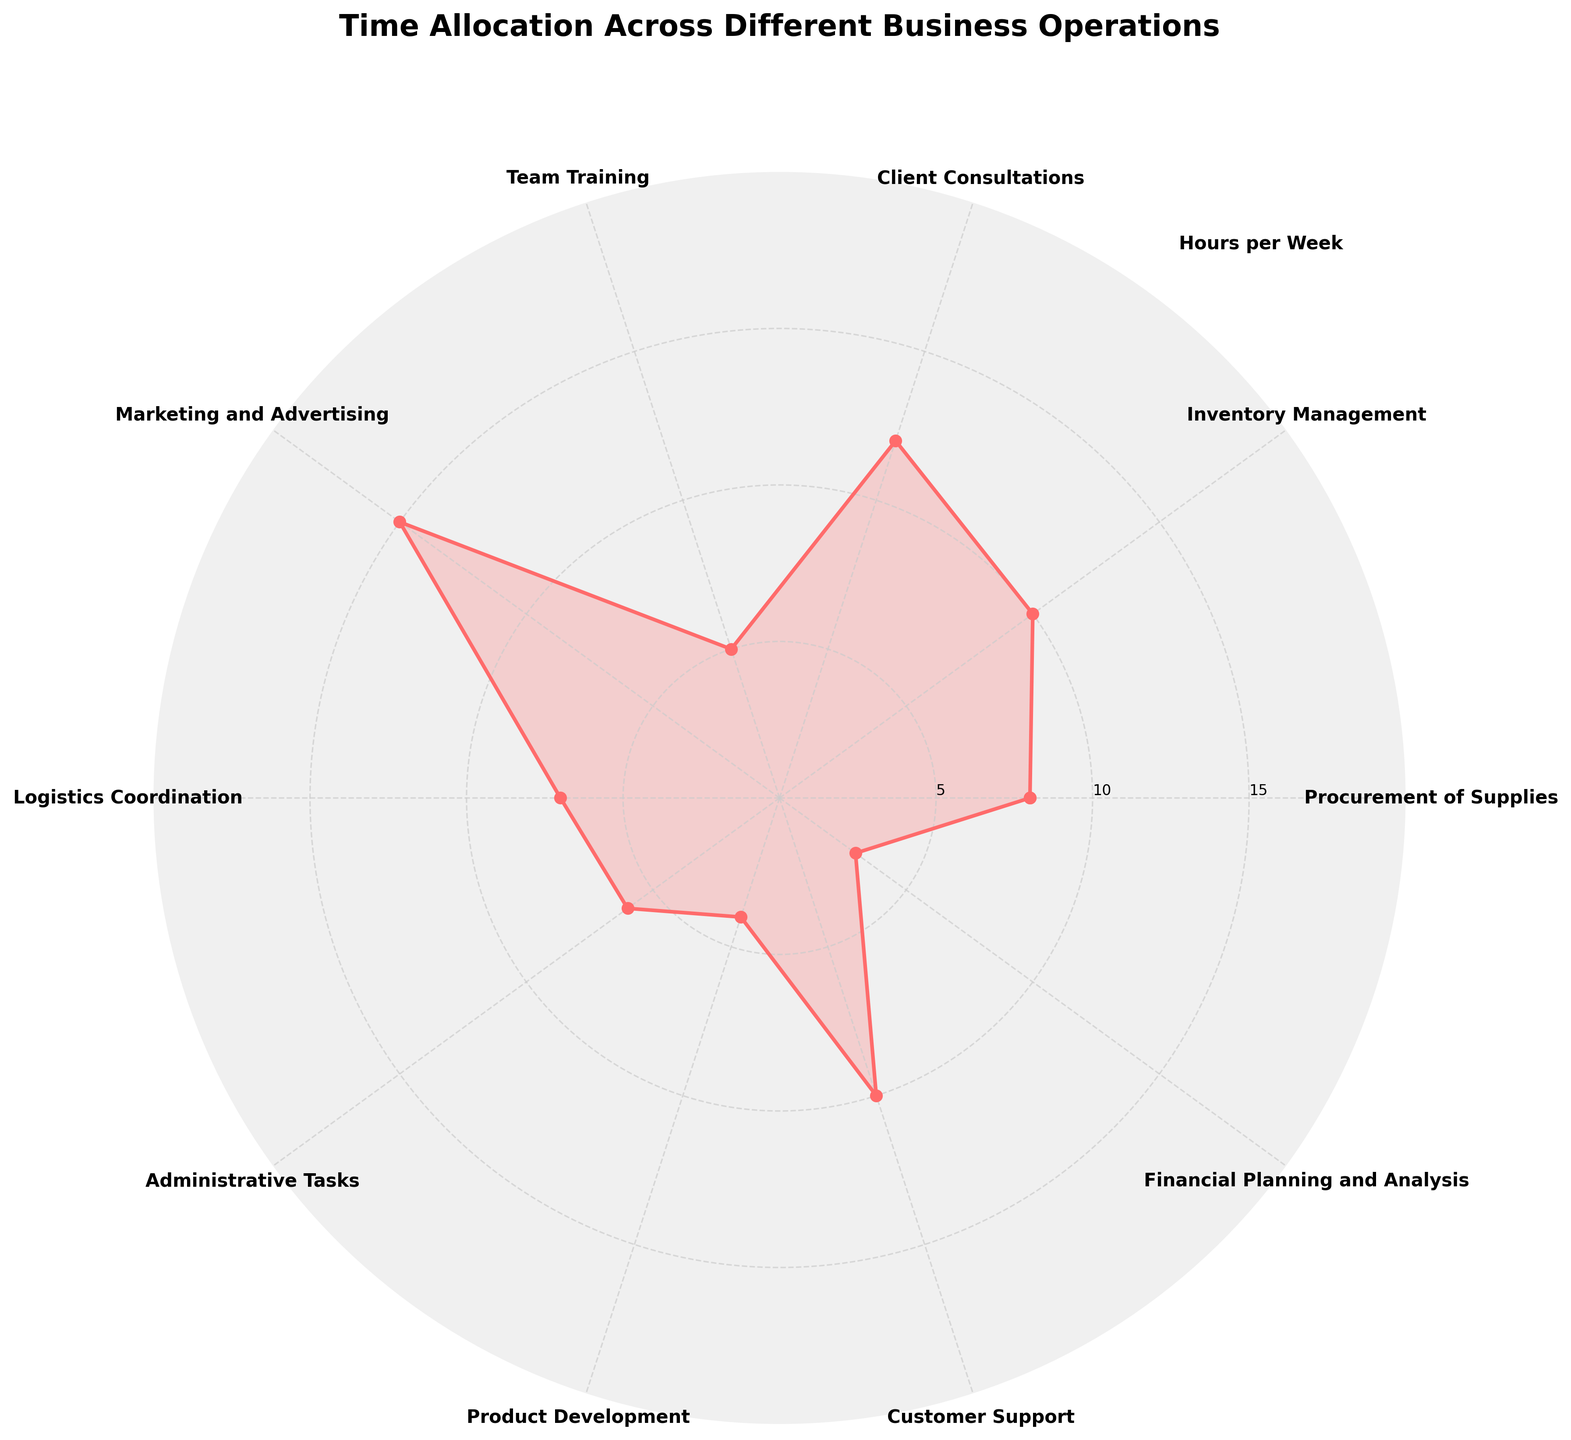What is the title of the rose chart? The title of the rose chart is written at the top of the chart in bold.
Answer: Time Allocation Across Different Business Operations Which business operation has the highest time allocation per week? The business operation with the highest value will have the largest segment on the rose chart, extending the farthest from the center.
Answer: Marketing and Advertising How many hours per week are allocated to Inventory Management? Locate the segment labeled 'Inventory Management' and check the radial distance associated with it.
Answer: 10 hours What is the total time allocated to Client Consultations and Customer Support combined? Find the hours allocated to each operation from the labels and add them together: Client Consultations (12) + Customer Support (10).
Answer: 22 hours Which business operation has the least time allocated? The business operation with the shortest segment will have the least hours.
Answer: Financial Planning and Analysis What is the sum of hours spent on Procurement of Supplies, Logistics Coordination, and Administrative Tasks? Locate each segment and sum their hours: Procurement of Supplies (8) + Logistics Coordination (7) + Administrative Tasks (6).
Answer: 21 hours How does the time allocated to Team Training compare to that of Product Development? Check the radial distance for both segments and compare the values: Team Training (5) vs. Product Development (4).
Answer: Team Training has 1 more hour than Product Development Is there any business operation that has an allocation of exactly 12 hours per week? Identify segments and their associated values to find if any of them is exactly 12 hours.
Answer: Yes, Client Consultations What is the average time allocated across all business operations? Add up the hours for all operations and divide by the number of operations (10): (8+10+12+5+15+7+6+4+10+3)/10.
Answer: 8 hours Which categories appear adjacent to Marketing and Advertising? Look at the rose chart and identify the segments immediately to the left and right of Marketing and Advertising.
Answer: Client Consultations and Logistics Coordination 